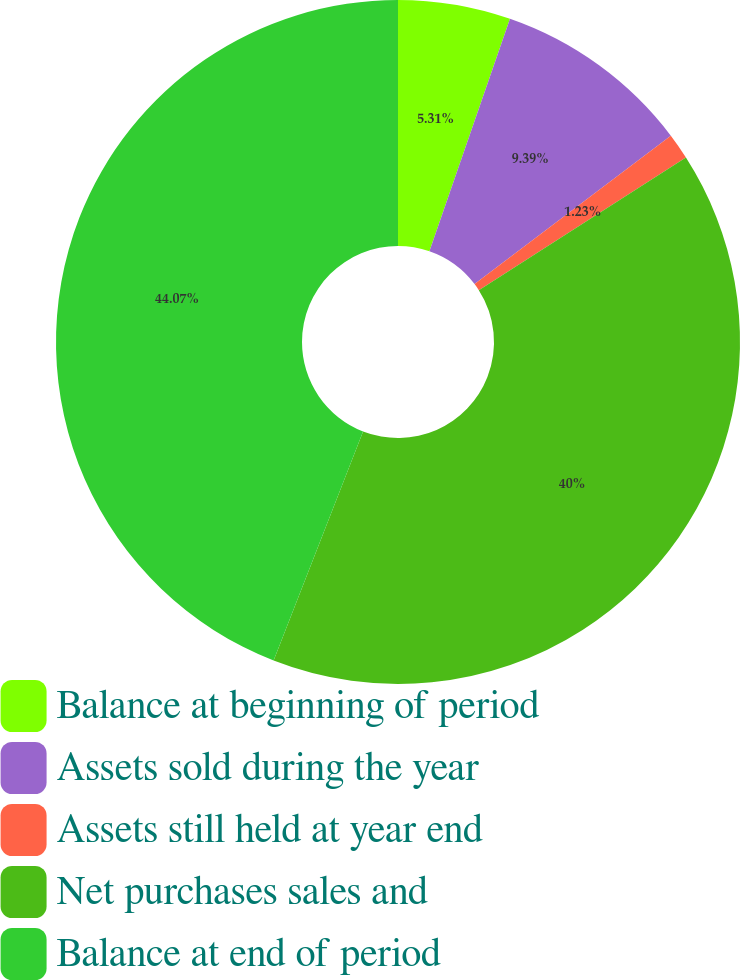Convert chart to OTSL. <chart><loc_0><loc_0><loc_500><loc_500><pie_chart><fcel>Balance at beginning of period<fcel>Assets sold during the year<fcel>Assets still held at year end<fcel>Net purchases sales and<fcel>Balance at end of period<nl><fcel>5.31%<fcel>9.39%<fcel>1.23%<fcel>40.0%<fcel>44.08%<nl></chart> 